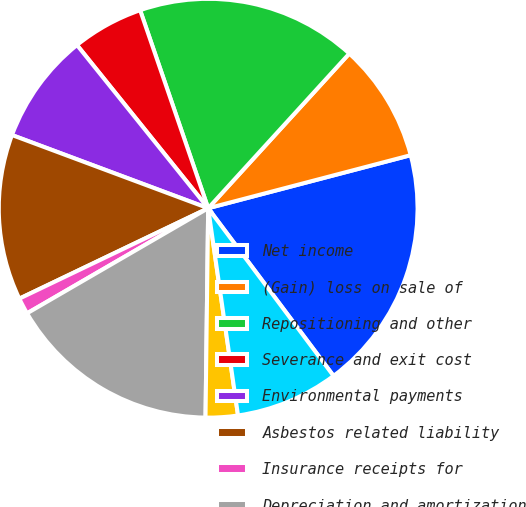<chart> <loc_0><loc_0><loc_500><loc_500><pie_chart><fcel>Net income<fcel>(Gain) loss on sale of<fcel>Repositioning and other<fcel>Severance and exit cost<fcel>Environmental payments<fcel>Asbestos related liability<fcel>Insurance receipts for<fcel>Depreciation and amortization<fcel>Undistributed earnings of<fcel>Deferred income taxes<nl><fcel>18.86%<fcel>9.15%<fcel>17.04%<fcel>5.51%<fcel>8.54%<fcel>12.79%<fcel>1.26%<fcel>16.43%<fcel>2.48%<fcel>7.94%<nl></chart> 